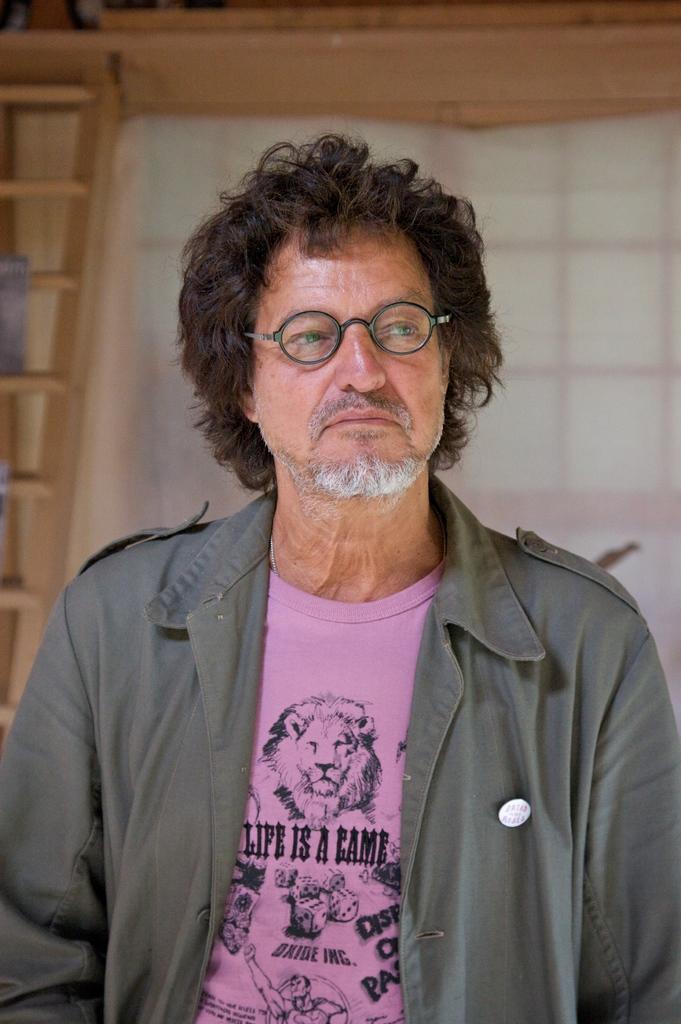Can you describe this image briefly? In this picture there is a old man wearing grey color jacket and pink t- shirt, looking on the right side. Behind there is a white color curtain and brown window. 